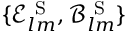<formula> <loc_0><loc_0><loc_500><loc_500>\{ \mathcal { E } _ { l m } ^ { S } , \mathcal { B } _ { l m } ^ { S } \}</formula> 